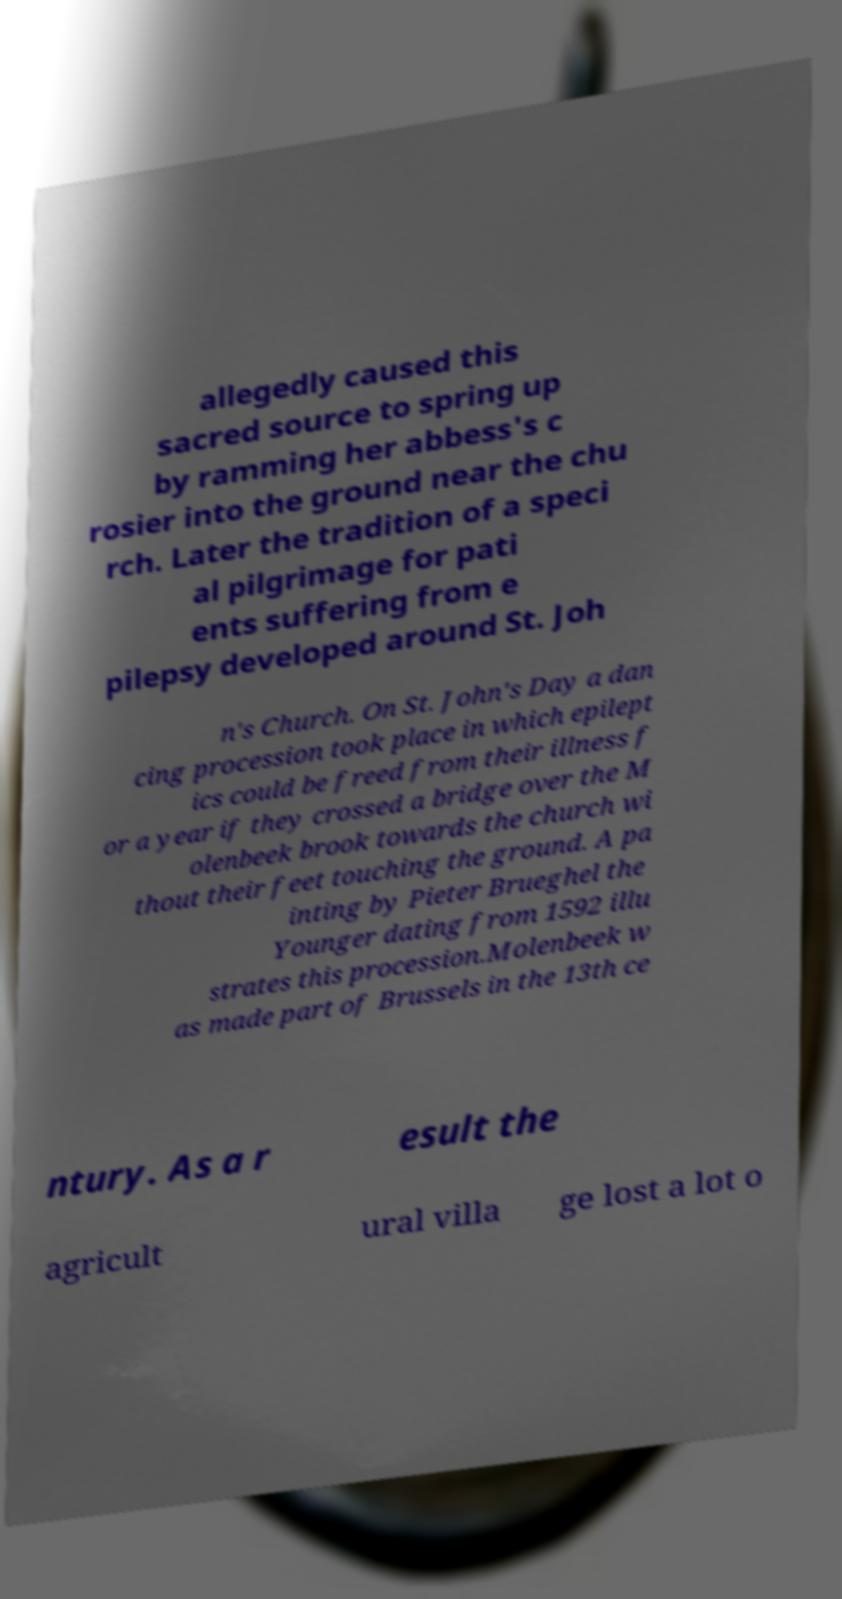There's text embedded in this image that I need extracted. Can you transcribe it verbatim? allegedly caused this sacred source to spring up by ramming her abbess's c rosier into the ground near the chu rch. Later the tradition of a speci al pilgrimage for pati ents suffering from e pilepsy developed around St. Joh n's Church. On St. John's Day a dan cing procession took place in which epilept ics could be freed from their illness f or a year if they crossed a bridge over the M olenbeek brook towards the church wi thout their feet touching the ground. A pa inting by Pieter Brueghel the Younger dating from 1592 illu strates this procession.Molenbeek w as made part of Brussels in the 13th ce ntury. As a r esult the agricult ural villa ge lost a lot o 